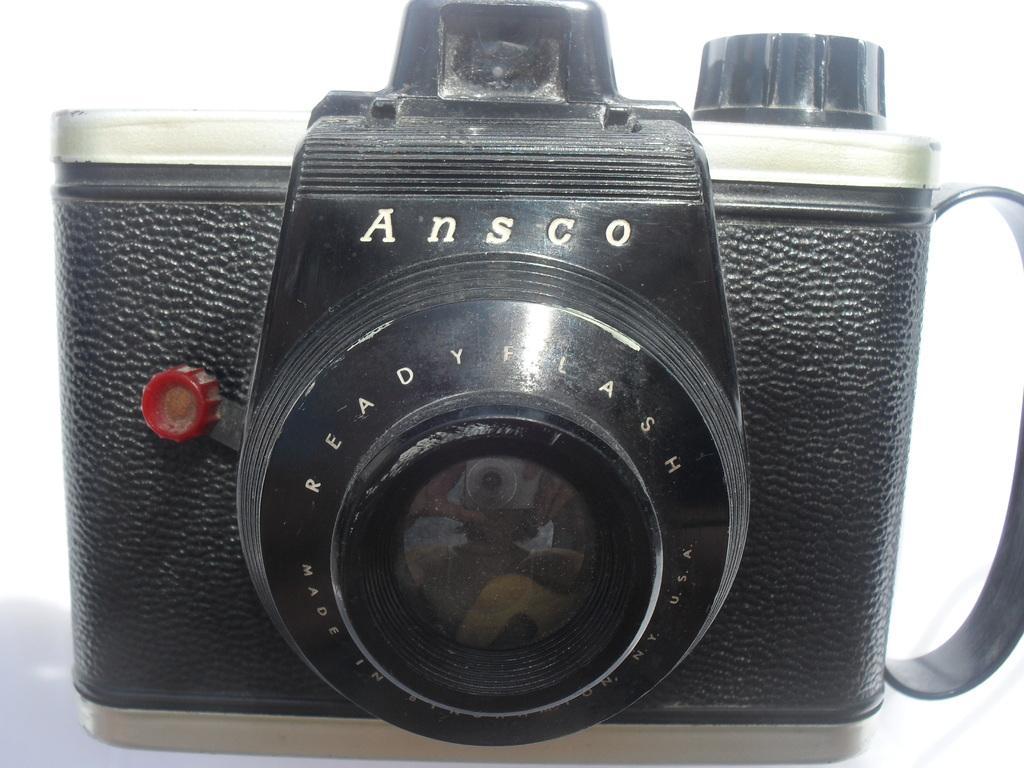Could you give a brief overview of what you see in this image? In the picture we can see a camera which is black in color is on floor. 